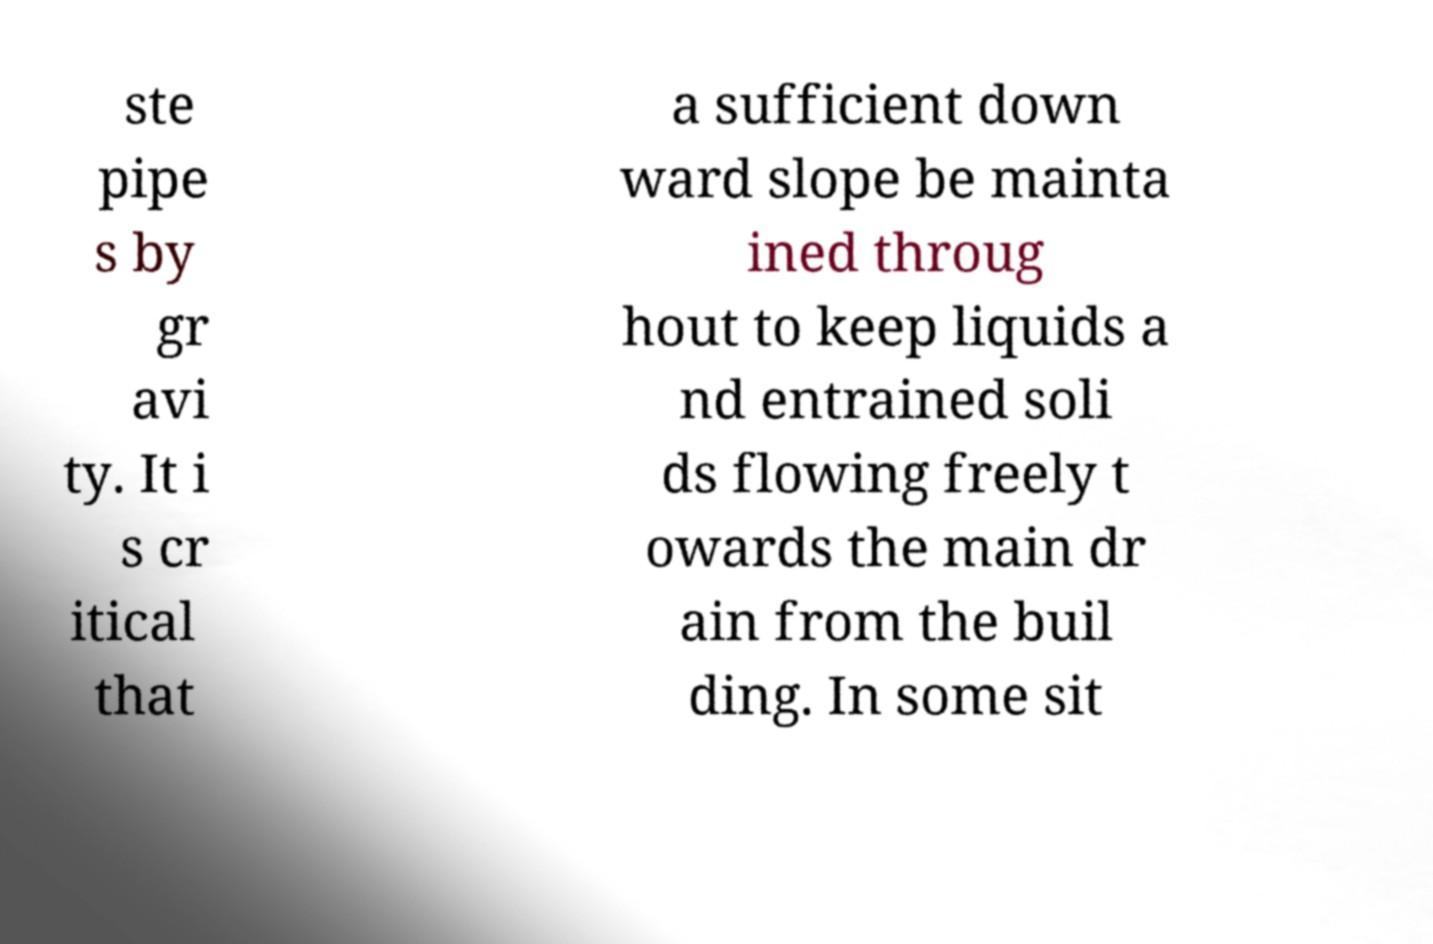Can you accurately transcribe the text from the provided image for me? ste pipe s by gr avi ty. It i s cr itical that a sufficient down ward slope be mainta ined throug hout to keep liquids a nd entrained soli ds flowing freely t owards the main dr ain from the buil ding. In some sit 